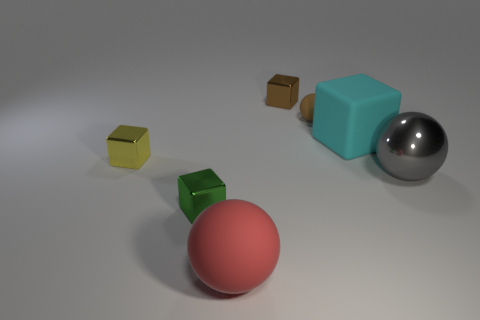Can you tell me the colors of the objects starting from the largest to the smallest? Certainly! Starting with the largest, there's a light blue cube, followed by a pink sphere, next is a shiny metal sphere, then a small green cube, and finally a tiny gold cube. 